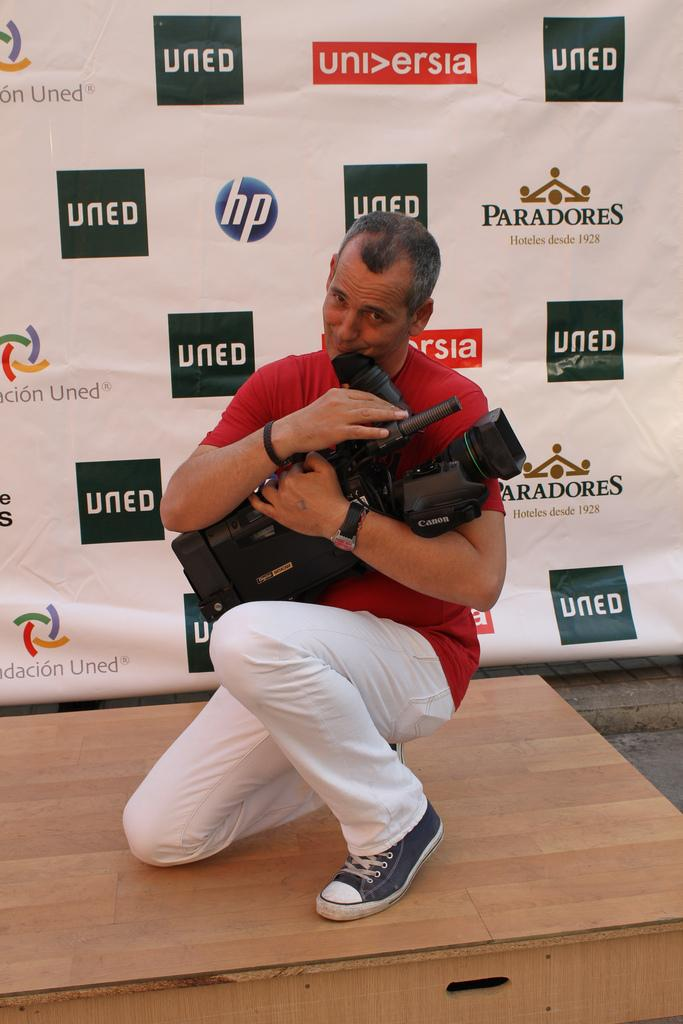Provide a one-sentence caption for the provided image. A man holds his camera lovingly as he stands in front of a wall with "uned" all over it. 